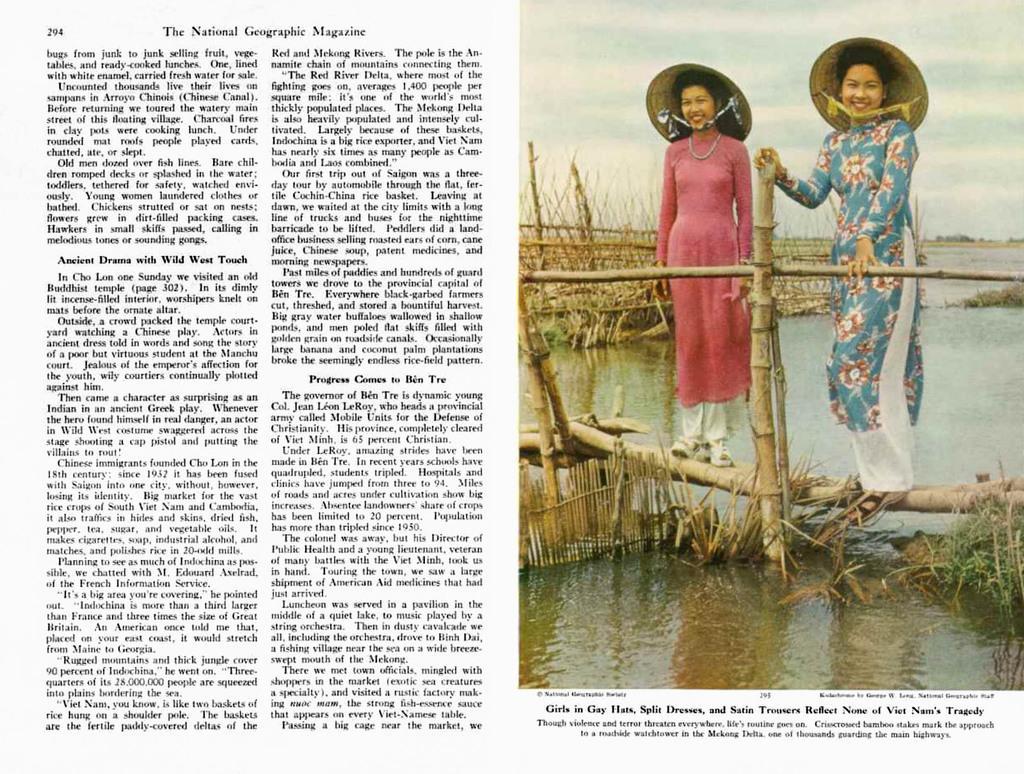Please provide a concise description of this image. This is an article and on the right, we can see two ladies standing on sticks and wearing hats. At the bottom, there is water and on the left, we can see text. 